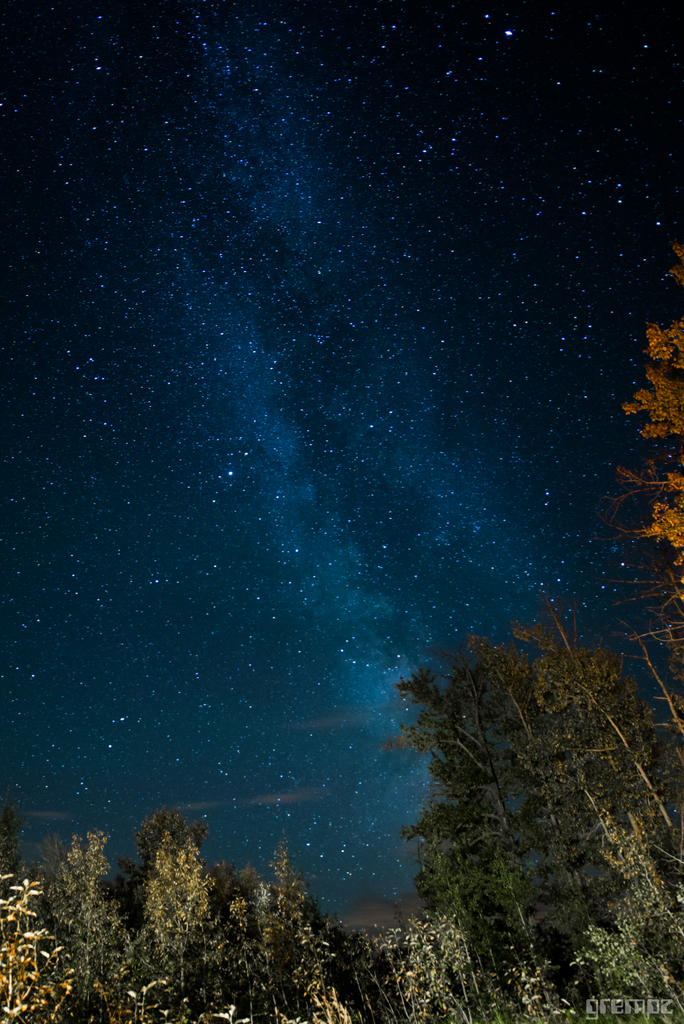What are the bright little specks and what causes them to be bright? The bright little specks in the image are stars. They are bright due to the nuclear fusion reactions taking place within them. These reactions convert hydrogen into helium, releasing a tremendous amount of energy in the form of light and heat. The brightness of each star as seen from Earth also depends on both its intrinsic luminosity (the total amount of energy emitted by the star) and its distance from us. Some of the brighter specks might also be planets or distant galaxies. The image also shows the diffuse glow of the Milky Way galaxy, of which our solar system is a part. The Milky Way's glow is the combined light of billions of stars that are too far away to be seen as individual points of light. 